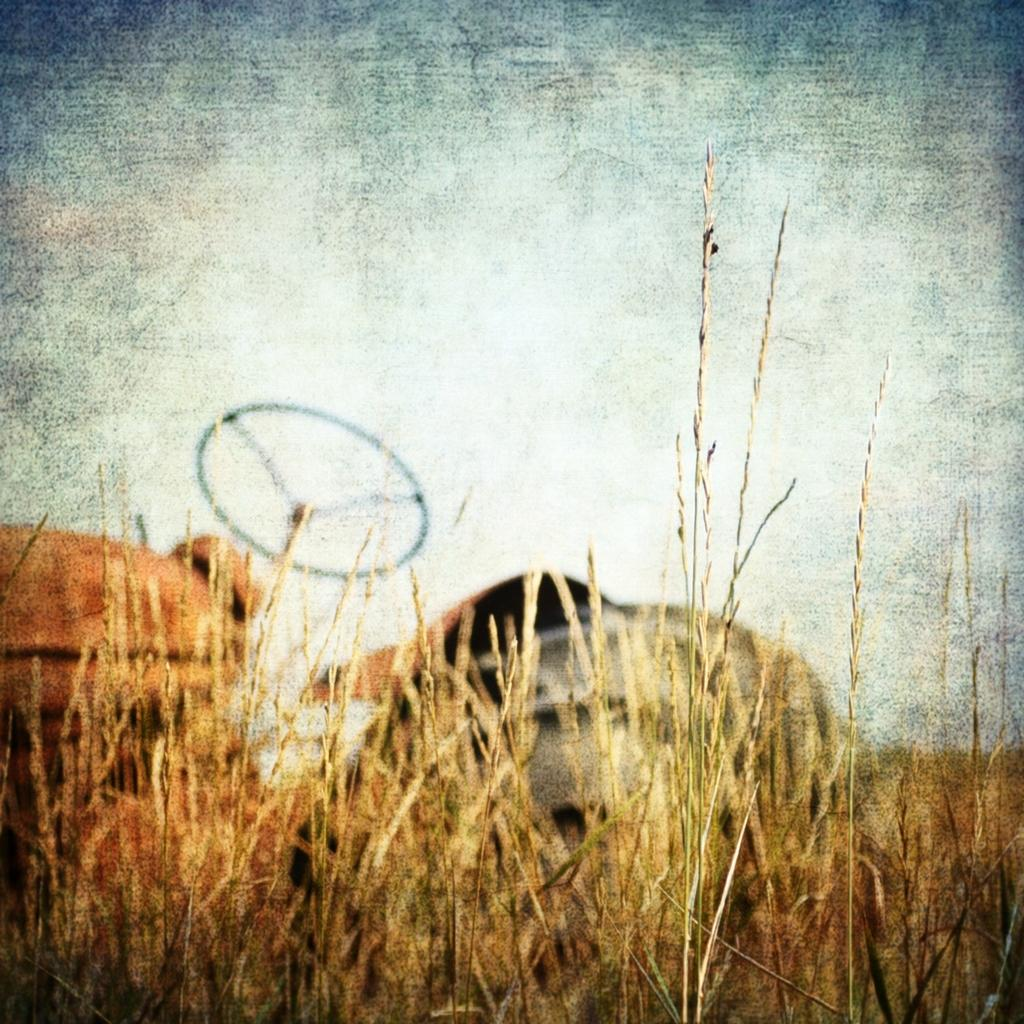What type of vegetation is present in the front of the image? There is grass in the front of the image. What can be seen in the background of the image? There is a vehicle visible in the background of the image. Can you observe any houses in the image? There is no house present in the image. What type of bead is used to decorate the grass in the image? There is no bead present in the image, as it features grass and a vehicle in the background. 